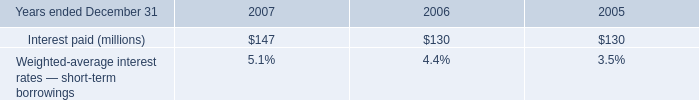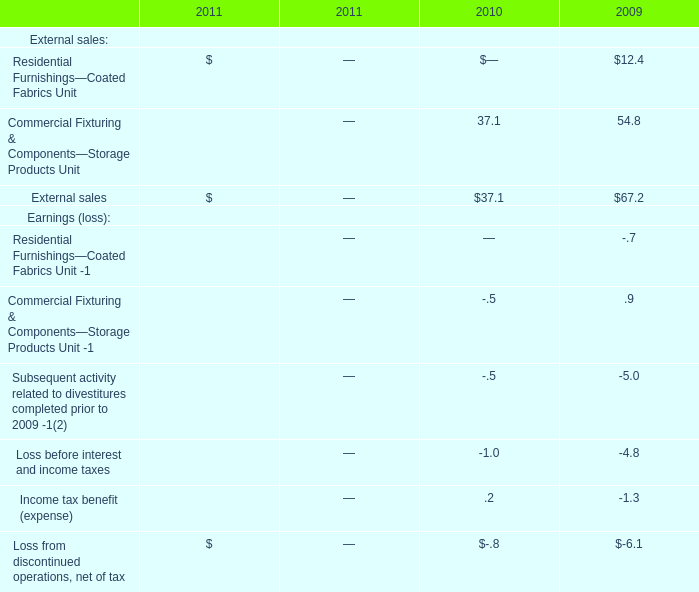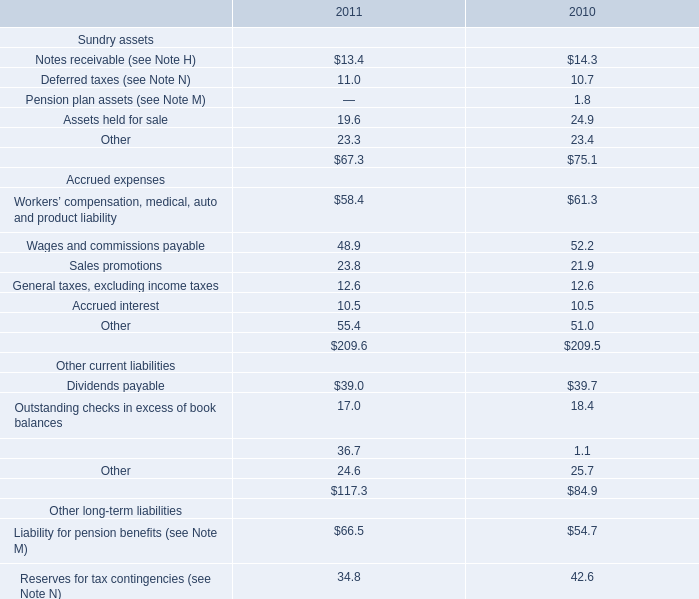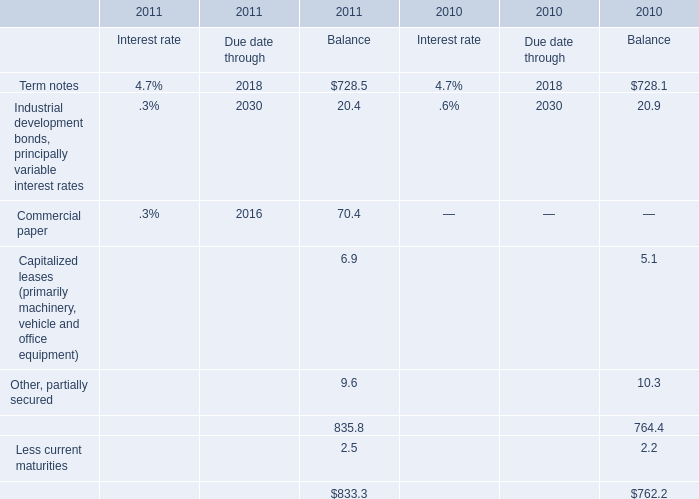Which year is the Balance for Capitalized leases (primarily machinery, vehicle and office equipment) higher? 
Answer: 2011. 